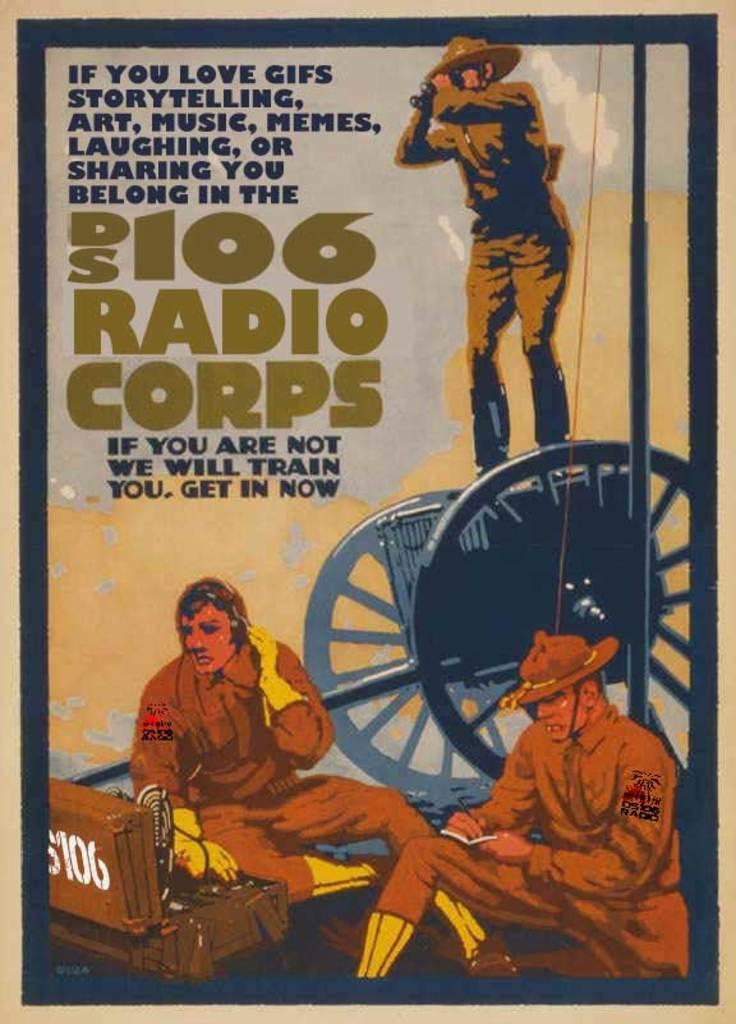What is the name of the radio corps?
Offer a terse response. Ds 106. What is the number on the box?
Your answer should be very brief. 106. 